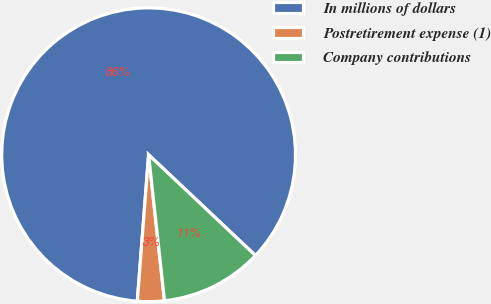Convert chart. <chart><loc_0><loc_0><loc_500><loc_500><pie_chart><fcel>In millions of dollars<fcel>Postretirement expense (1)<fcel>Company contributions<nl><fcel>85.81%<fcel>2.95%<fcel>11.24%<nl></chart> 